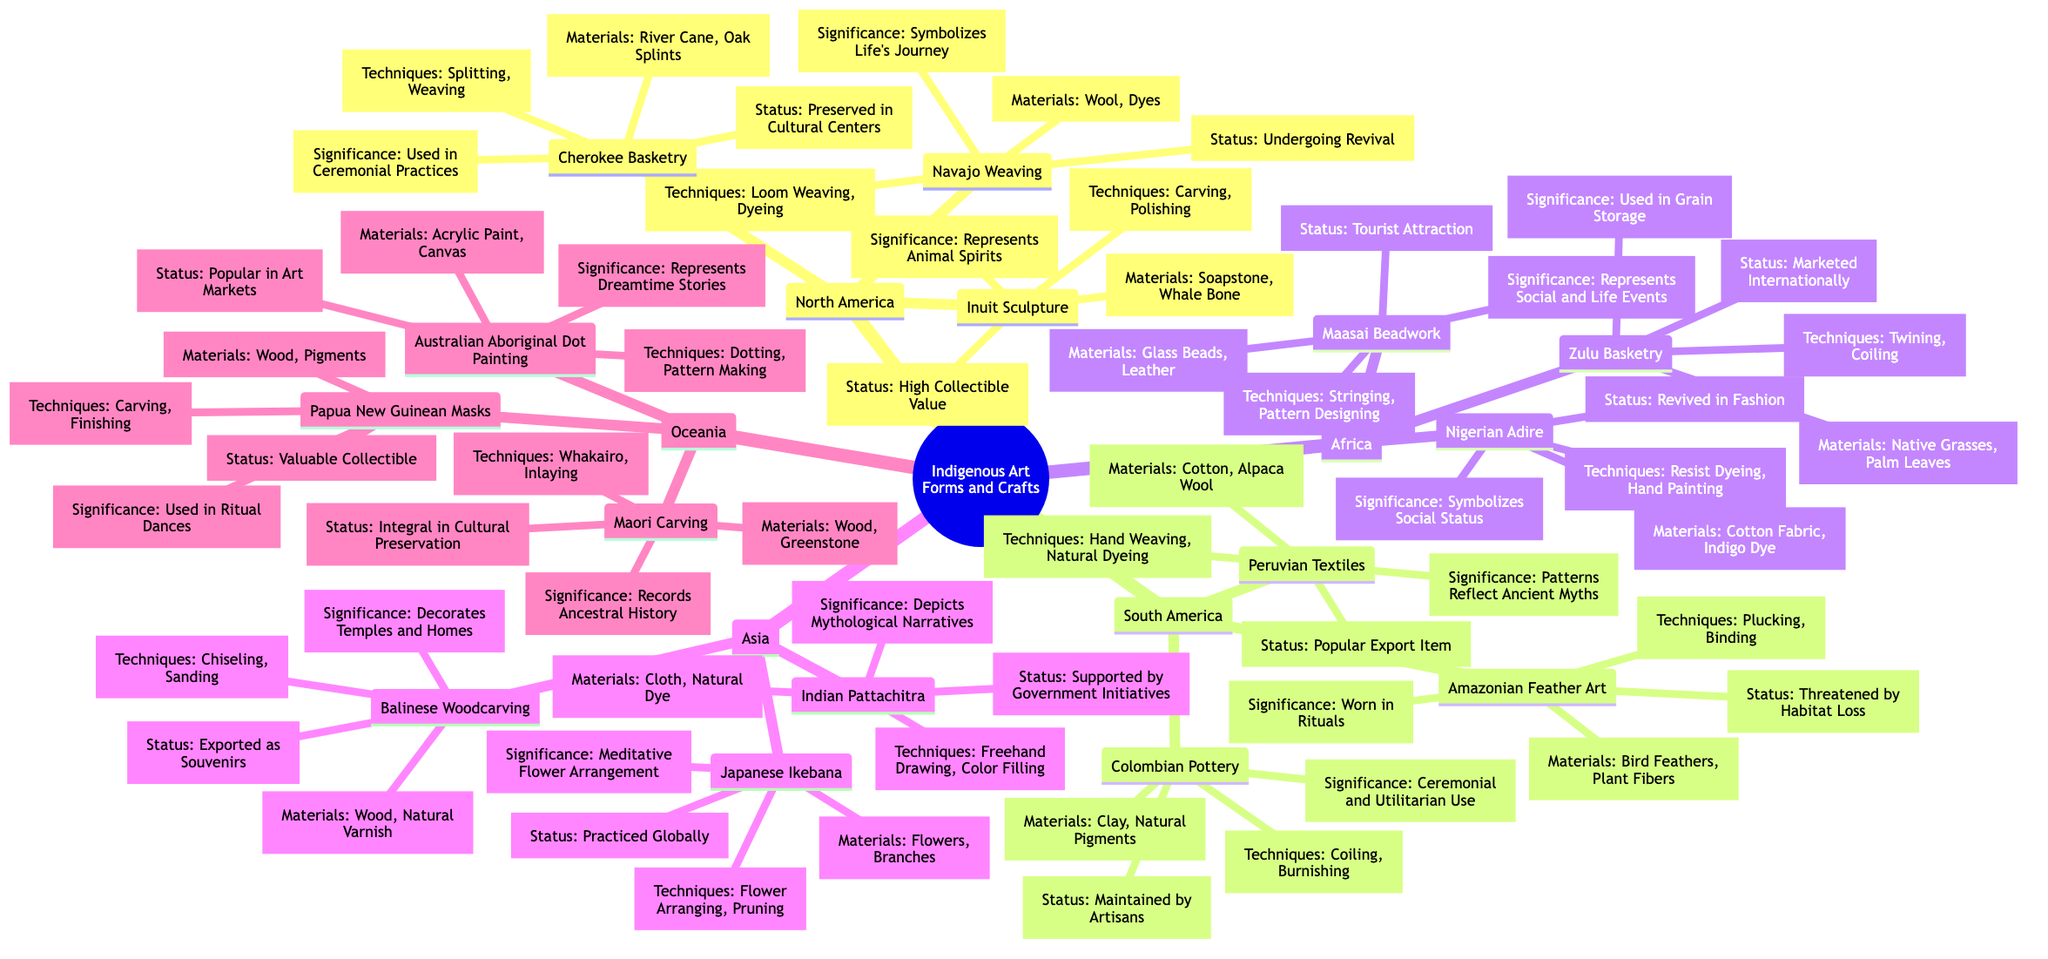What are the key practices listed for North America? The diagram states three key practices under North America: Navajo Weaving, Inuit Sculpture, and Cherokee Basketry. This information is directly found in the "Key Practices" node for North America.
Answer: Navajo Weaving, Inuit Sculpture, Cherokee Basketry Which crafting technique is used in Peruvian Textiles? The diagram indicates that Peruvian Textiles involve Hand Weaving and Natural Dyeing as crafting techniques. Specifically, these are mentioned under the "Techniques" node for Peruvian Textiles.
Answer: Hand Weaving, Natural Dyeing How many key practices are listed for Oceania? In the diagram for Oceania, there are three key practices: Australian Aboriginal Dot Painting, Maori Carving, and Papua New Guinean Masks. By counting these practices, we find there are three distinct practices.
Answer: 3 What materials are used in Maasai Beadwork? The diagram states that Maasai Beadwork uses Glass Beads and Leather as its materials. This direct information is located under the "Materials Used" section for Maasai Beadwork.
Answer: Glass Beads, Leather What is the artistic significance of Japanese Ikebana? According to the diagram, Japanese Ikebana is described as a Meditative Flower Arrangement, found in the "Significance" section of Japanese Ikebana in the Asia category.
Answer: Meditative Flower Arrangement How does Amazonian Feather Art's current status compare to that of Colombian Pottery? The diagram shows that Amazonian Feather Art is Threatened by Habitat Loss, while Colombian Pottery is Maintained by Artisans. To compare, we look at these two statuses directly under each practice's "Current Status" node.
Answer: Threatened by Habitat Loss, Maintained by Artisans Which indigenous art form from Africa symbolizes social status? The diagram highlights Nigerian Adire as symbolizing Social Status. This information is contained within the "Artistic Significance" part of Nigerian Adire in the Africa section of the diagram.
Answer: Nigerian Adire What crafting technique is used in Australian Aboriginal Dot Painting? The diagram specifies that Australian Aboriginal Dot Painting employs Dotting and Pattern Making as its crafting techniques, found under the corresponding "Techniques" node in the Oceania section.
Answer: Dotting, Pattern Making What is the current status of Inuit Sculpture? The diagram notes that the current status of Inuit Sculpture is High Collectible Value. This is relayed in the "Current Status" section for Inuit Sculpture under North America.
Answer: High Collectible Value 